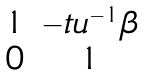<formula> <loc_0><loc_0><loc_500><loc_500>\begin{matrix} 1 & - t u ^ { - 1 } \beta \\ 0 & 1 \end{matrix}</formula> 